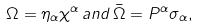Convert formula to latex. <formula><loc_0><loc_0><loc_500><loc_500>\Omega = \eta _ { \alpha } \chi ^ { \alpha } \, a n d \, \bar { \Omega } = P ^ { \alpha } \sigma _ { \alpha } ,</formula> 